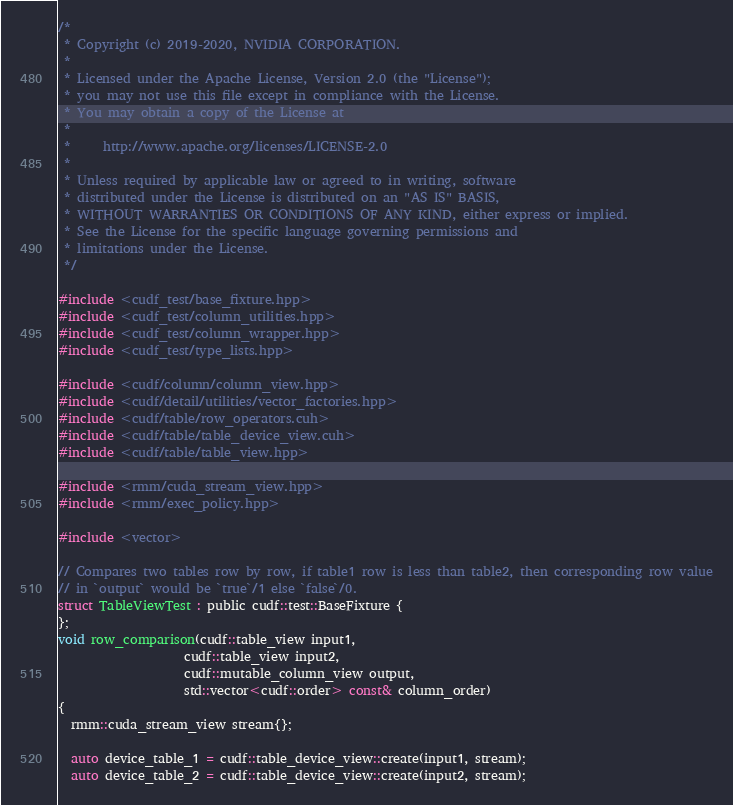<code> <loc_0><loc_0><loc_500><loc_500><_Cuda_>/*
 * Copyright (c) 2019-2020, NVIDIA CORPORATION.
 *
 * Licensed under the Apache License, Version 2.0 (the "License");
 * you may not use this file except in compliance with the License.
 * You may obtain a copy of the License at
 *
 *     http://www.apache.org/licenses/LICENSE-2.0
 *
 * Unless required by applicable law or agreed to in writing, software
 * distributed under the License is distributed on an "AS IS" BASIS,
 * WITHOUT WARRANTIES OR CONDITIONS OF ANY KIND, either express or implied.
 * See the License for the specific language governing permissions and
 * limitations under the License.
 */

#include <cudf_test/base_fixture.hpp>
#include <cudf_test/column_utilities.hpp>
#include <cudf_test/column_wrapper.hpp>
#include <cudf_test/type_lists.hpp>

#include <cudf/column/column_view.hpp>
#include <cudf/detail/utilities/vector_factories.hpp>
#include <cudf/table/row_operators.cuh>
#include <cudf/table/table_device_view.cuh>
#include <cudf/table/table_view.hpp>

#include <rmm/cuda_stream_view.hpp>
#include <rmm/exec_policy.hpp>

#include <vector>

// Compares two tables row by row, if table1 row is less than table2, then corresponding row value
// in `output` would be `true`/1 else `false`/0.
struct TableViewTest : public cudf::test::BaseFixture {
};
void row_comparison(cudf::table_view input1,
                    cudf::table_view input2,
                    cudf::mutable_column_view output,
                    std::vector<cudf::order> const& column_order)
{
  rmm::cuda_stream_view stream{};

  auto device_table_1 = cudf::table_device_view::create(input1, stream);
  auto device_table_2 = cudf::table_device_view::create(input2, stream);</code> 